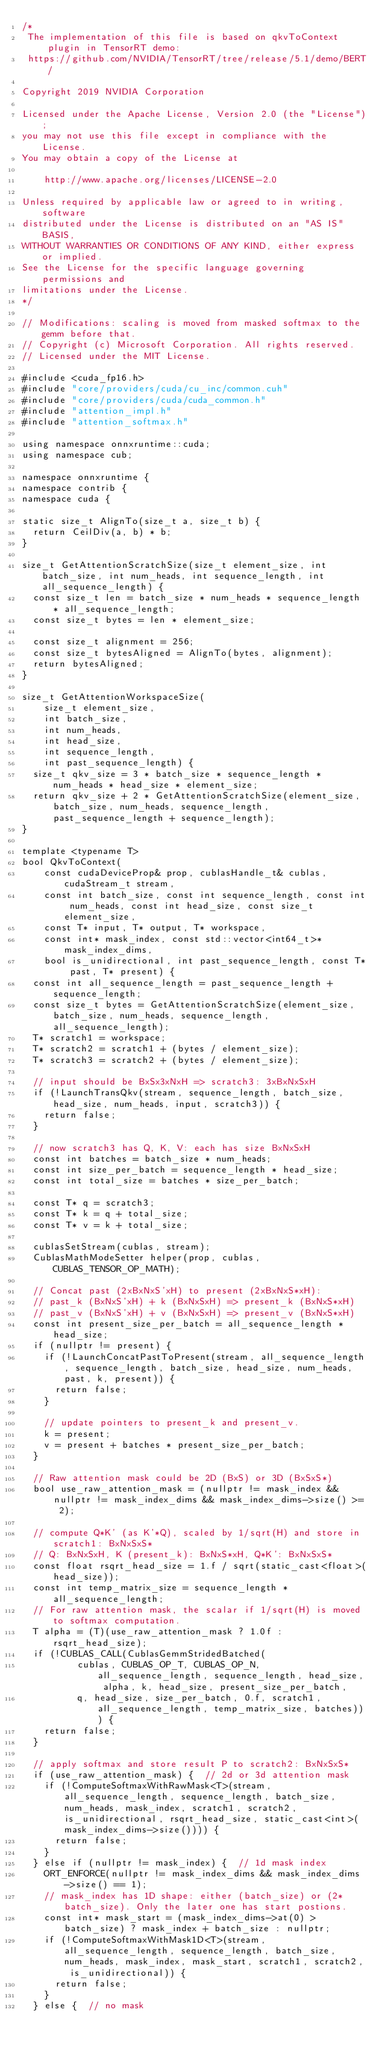Convert code to text. <code><loc_0><loc_0><loc_500><loc_500><_Cuda_>/*
 The implementation of this file is based on qkvToContext plugin in TensorRT demo:
 https://github.com/NVIDIA/TensorRT/tree/release/5.1/demo/BERT/

Copyright 2019 NVIDIA Corporation

Licensed under the Apache License, Version 2.0 (the "License");
you may not use this file except in compliance with the License.
You may obtain a copy of the License at

    http://www.apache.org/licenses/LICENSE-2.0

Unless required by applicable law or agreed to in writing, software
distributed under the License is distributed on an "AS IS" BASIS,
WITHOUT WARRANTIES OR CONDITIONS OF ANY KIND, either express or implied.
See the License for the specific language governing permissions and
limitations under the License.
*/

// Modifications: scaling is moved from masked softmax to the gemm before that.
// Copyright (c) Microsoft Corporation. All rights reserved.
// Licensed under the MIT License.

#include <cuda_fp16.h>
#include "core/providers/cuda/cu_inc/common.cuh"
#include "core/providers/cuda/cuda_common.h"
#include "attention_impl.h"
#include "attention_softmax.h"

using namespace onnxruntime::cuda;
using namespace cub;

namespace onnxruntime {
namespace contrib {
namespace cuda {

static size_t AlignTo(size_t a, size_t b) {
  return CeilDiv(a, b) * b;
}

size_t GetAttentionScratchSize(size_t element_size, int batch_size, int num_heads, int sequence_length, int all_sequence_length) {
  const size_t len = batch_size * num_heads * sequence_length * all_sequence_length;
  const size_t bytes = len * element_size;

  const size_t alignment = 256;
  const size_t bytesAligned = AlignTo(bytes, alignment);
  return bytesAligned;
}

size_t GetAttentionWorkspaceSize(
    size_t element_size,
    int batch_size,
    int num_heads,
    int head_size,
    int sequence_length,
    int past_sequence_length) {
  size_t qkv_size = 3 * batch_size * sequence_length * num_heads * head_size * element_size;
  return qkv_size + 2 * GetAttentionScratchSize(element_size, batch_size, num_heads, sequence_length, past_sequence_length + sequence_length);
}

template <typename T>
bool QkvToContext(
    const cudaDeviceProp& prop, cublasHandle_t& cublas, cudaStream_t stream,
    const int batch_size, const int sequence_length, const int num_heads, const int head_size, const size_t element_size,
    const T* input, T* output, T* workspace,
    const int* mask_index, const std::vector<int64_t>* mask_index_dims,
    bool is_unidirectional, int past_sequence_length, const T* past, T* present) {
  const int all_sequence_length = past_sequence_length + sequence_length;
  const size_t bytes = GetAttentionScratchSize(element_size, batch_size, num_heads, sequence_length, all_sequence_length);
  T* scratch1 = workspace;
  T* scratch2 = scratch1 + (bytes / element_size);
  T* scratch3 = scratch2 + (bytes / element_size);

  // input should be BxSx3xNxH => scratch3: 3xBxNxSxH
  if (!LaunchTransQkv(stream, sequence_length, batch_size, head_size, num_heads, input, scratch3)) {
    return false;
  }

  // now scratch3 has Q, K, V: each has size BxNxSxH
  const int batches = batch_size * num_heads;
  const int size_per_batch = sequence_length * head_size;
  const int total_size = batches * size_per_batch;

  const T* q = scratch3;
  const T* k = q + total_size;
  const T* v = k + total_size;

  cublasSetStream(cublas, stream);
  CublasMathModeSetter helper(prop, cublas, CUBLAS_TENSOR_OP_MATH);

  // Concat past (2xBxNxS'xH) to present (2xBxNxS*xH):
  // past_k (BxNxS'xH) + k (BxNxSxH) => present_k (BxNxS*xH)
  // past_v (BxNxS'xH) + v (BxNxSxH) => present_v (BxNxS*xH)
  const int present_size_per_batch = all_sequence_length * head_size;
  if (nullptr != present) {
    if (!LaunchConcatPastToPresent(stream, all_sequence_length, sequence_length, batch_size, head_size, num_heads, past, k, present)) {
      return false;
    }

    // update pointers to present_k and present_v.
    k = present;
    v = present + batches * present_size_per_batch;
  }

  // Raw attention mask could be 2D (BxS) or 3D (BxSxS*)
  bool use_raw_attention_mask = (nullptr != mask_index && nullptr != mask_index_dims && mask_index_dims->size() >= 2);

  // compute Q*K' (as K'*Q), scaled by 1/sqrt(H) and store in scratch1: BxNxSxS*
  // Q: BxNxSxH, K (present_k): BxNxS*xH, Q*K': BxNxSxS*
  const float rsqrt_head_size = 1.f / sqrt(static_cast<float>(head_size));
  const int temp_matrix_size = sequence_length * all_sequence_length;
  // For raw attention mask, the scalar if 1/sqrt(H) is moved to softmax computation.
  T alpha = (T)(use_raw_attention_mask ? 1.0f : rsqrt_head_size);
  if (!CUBLAS_CALL(CublasGemmStridedBatched(
          cublas, CUBLAS_OP_T, CUBLAS_OP_N, all_sequence_length, sequence_length, head_size, alpha, k, head_size, present_size_per_batch,
          q, head_size, size_per_batch, 0.f, scratch1, all_sequence_length, temp_matrix_size, batches))) {
    return false;
  }

  // apply softmax and store result P to scratch2: BxNxSxS*
  if (use_raw_attention_mask) {  // 2d or 3d attention mask
    if (!ComputeSoftmaxWithRawMask<T>(stream, all_sequence_length, sequence_length, batch_size, num_heads, mask_index, scratch1, scratch2, is_unidirectional, rsqrt_head_size, static_cast<int>(mask_index_dims->size()))) {
      return false;
    }
  } else if (nullptr != mask_index) {  // 1d mask index
    ORT_ENFORCE(nullptr != mask_index_dims && mask_index_dims->size() == 1);
    // mask_index has 1D shape: either (batch_size) or (2*batch_size). Only the later one has start postions.
    const int* mask_start = (mask_index_dims->at(0) > batch_size) ? mask_index + batch_size : nullptr;
    if (!ComputeSoftmaxWithMask1D<T>(stream, all_sequence_length, sequence_length, batch_size, num_heads, mask_index, mask_start, scratch1, scratch2, is_unidirectional)) {
      return false;
    }
  } else {  // no mask</code> 